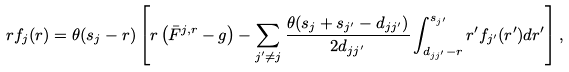Convert formula to latex. <formula><loc_0><loc_0><loc_500><loc_500>r f _ { j } ( r ) = \theta ( s _ { j } - r ) \left [ r \left ( \bar { F } ^ { j , r } - g \right ) - \sum _ { j ^ { \prime } \neq j } \frac { \theta ( s _ { j } + s _ { j ^ { \prime } } - d _ { j j ^ { \prime } } ) } { 2 d _ { j j ^ { \prime } } } \int _ { d _ { j j ^ { \prime } } - r } ^ { s _ { j ^ { \prime } } } r ^ { \prime } f _ { j ^ { \prime } } ( r ^ { \prime } ) d r ^ { \prime } \right ] ,</formula> 